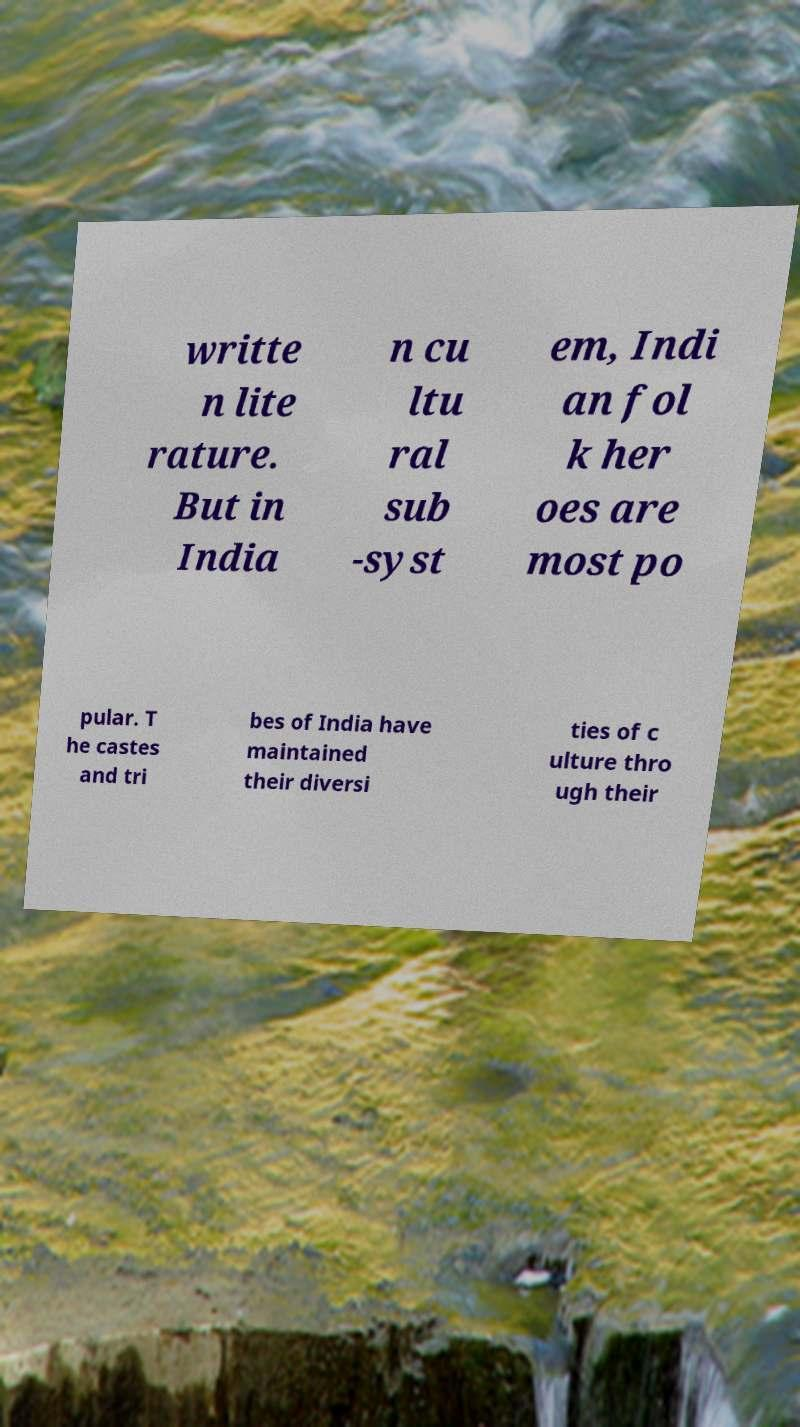For documentation purposes, I need the text within this image transcribed. Could you provide that? writte n lite rature. But in India n cu ltu ral sub -syst em, Indi an fol k her oes are most po pular. T he castes and tri bes of India have maintained their diversi ties of c ulture thro ugh their 